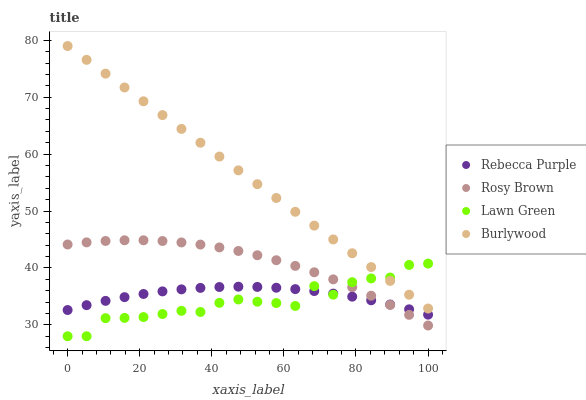Does Lawn Green have the minimum area under the curve?
Answer yes or no. Yes. Does Burlywood have the maximum area under the curve?
Answer yes or no. Yes. Does Rosy Brown have the minimum area under the curve?
Answer yes or no. No. Does Rosy Brown have the maximum area under the curve?
Answer yes or no. No. Is Burlywood the smoothest?
Answer yes or no. Yes. Is Lawn Green the roughest?
Answer yes or no. Yes. Is Rosy Brown the smoothest?
Answer yes or no. No. Is Rosy Brown the roughest?
Answer yes or no. No. Does Lawn Green have the lowest value?
Answer yes or no. Yes. Does Rosy Brown have the lowest value?
Answer yes or no. No. Does Burlywood have the highest value?
Answer yes or no. Yes. Does Lawn Green have the highest value?
Answer yes or no. No. Is Rosy Brown less than Burlywood?
Answer yes or no. Yes. Is Burlywood greater than Rosy Brown?
Answer yes or no. Yes. Does Lawn Green intersect Rebecca Purple?
Answer yes or no. Yes. Is Lawn Green less than Rebecca Purple?
Answer yes or no. No. Is Lawn Green greater than Rebecca Purple?
Answer yes or no. No. Does Rosy Brown intersect Burlywood?
Answer yes or no. No. 